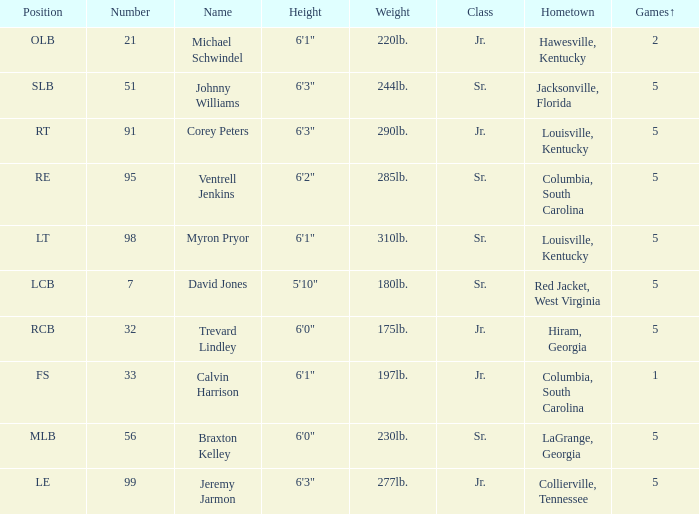How many players were 6'1" and from Columbia, South Carolina? 1.0. 